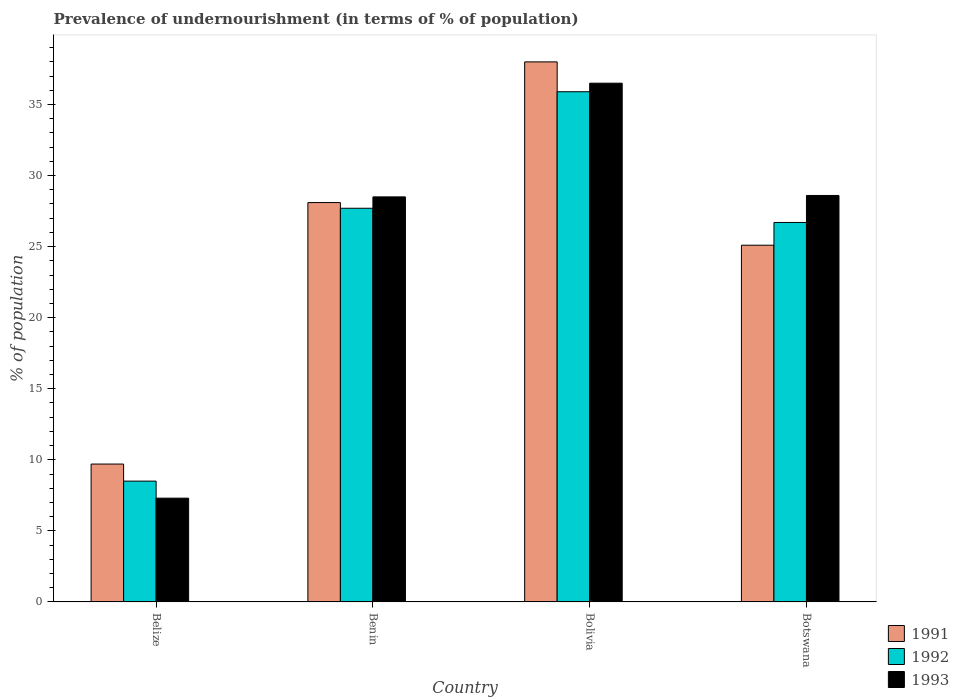Are the number of bars per tick equal to the number of legend labels?
Make the answer very short. Yes. What is the label of the 1st group of bars from the left?
Give a very brief answer. Belize. What is the percentage of undernourished population in 1993 in Benin?
Your answer should be compact. 28.5. Across all countries, what is the maximum percentage of undernourished population in 1993?
Keep it short and to the point. 36.5. In which country was the percentage of undernourished population in 1992 minimum?
Offer a very short reply. Belize. What is the total percentage of undernourished population in 1991 in the graph?
Provide a succinct answer. 100.9. What is the difference between the percentage of undernourished population in 1993 in Bolivia and that in Botswana?
Make the answer very short. 7.9. What is the difference between the percentage of undernourished population in 1991 in Bolivia and the percentage of undernourished population in 1993 in Benin?
Your answer should be compact. 9.5. What is the average percentage of undernourished population in 1993 per country?
Offer a very short reply. 25.23. What is the difference between the percentage of undernourished population of/in 1992 and percentage of undernourished population of/in 1991 in Benin?
Give a very brief answer. -0.4. In how many countries, is the percentage of undernourished population in 1992 greater than 14 %?
Your answer should be very brief. 3. What is the ratio of the percentage of undernourished population in 1992 in Belize to that in Bolivia?
Your answer should be compact. 0.24. Is the percentage of undernourished population in 1991 in Belize less than that in Botswana?
Your response must be concise. Yes. Is the difference between the percentage of undernourished population in 1992 in Belize and Bolivia greater than the difference between the percentage of undernourished population in 1991 in Belize and Bolivia?
Provide a succinct answer. Yes. What is the difference between the highest and the second highest percentage of undernourished population in 1991?
Ensure brevity in your answer.  -3. What is the difference between the highest and the lowest percentage of undernourished population in 1993?
Provide a succinct answer. 29.2. In how many countries, is the percentage of undernourished population in 1991 greater than the average percentage of undernourished population in 1991 taken over all countries?
Make the answer very short. 2. What does the 3rd bar from the left in Belize represents?
Your answer should be very brief. 1993. Is it the case that in every country, the sum of the percentage of undernourished population in 1992 and percentage of undernourished population in 1993 is greater than the percentage of undernourished population in 1991?
Provide a short and direct response. Yes. Are all the bars in the graph horizontal?
Offer a very short reply. No. Are the values on the major ticks of Y-axis written in scientific E-notation?
Provide a succinct answer. No. Does the graph contain any zero values?
Offer a terse response. No. Does the graph contain grids?
Your answer should be compact. No. Where does the legend appear in the graph?
Give a very brief answer. Bottom right. How are the legend labels stacked?
Make the answer very short. Vertical. What is the title of the graph?
Offer a terse response. Prevalence of undernourishment (in terms of % of population). Does "1970" appear as one of the legend labels in the graph?
Offer a terse response. No. What is the label or title of the X-axis?
Keep it short and to the point. Country. What is the label or title of the Y-axis?
Offer a very short reply. % of population. What is the % of population of 1991 in Benin?
Ensure brevity in your answer.  28.1. What is the % of population of 1992 in Benin?
Provide a succinct answer. 27.7. What is the % of population in 1993 in Benin?
Provide a succinct answer. 28.5. What is the % of population in 1991 in Bolivia?
Offer a terse response. 38. What is the % of population in 1992 in Bolivia?
Give a very brief answer. 35.9. What is the % of population in 1993 in Bolivia?
Keep it short and to the point. 36.5. What is the % of population of 1991 in Botswana?
Make the answer very short. 25.1. What is the % of population of 1992 in Botswana?
Offer a very short reply. 26.7. What is the % of population of 1993 in Botswana?
Your answer should be compact. 28.6. Across all countries, what is the maximum % of population of 1991?
Keep it short and to the point. 38. Across all countries, what is the maximum % of population of 1992?
Offer a very short reply. 35.9. Across all countries, what is the maximum % of population of 1993?
Your answer should be compact. 36.5. What is the total % of population of 1991 in the graph?
Your answer should be compact. 100.9. What is the total % of population in 1992 in the graph?
Offer a terse response. 98.8. What is the total % of population in 1993 in the graph?
Offer a terse response. 100.9. What is the difference between the % of population in 1991 in Belize and that in Benin?
Provide a succinct answer. -18.4. What is the difference between the % of population in 1992 in Belize and that in Benin?
Your answer should be very brief. -19.2. What is the difference between the % of population of 1993 in Belize and that in Benin?
Give a very brief answer. -21.2. What is the difference between the % of population in 1991 in Belize and that in Bolivia?
Provide a succinct answer. -28.3. What is the difference between the % of population in 1992 in Belize and that in Bolivia?
Offer a very short reply. -27.4. What is the difference between the % of population in 1993 in Belize and that in Bolivia?
Provide a succinct answer. -29.2. What is the difference between the % of population in 1991 in Belize and that in Botswana?
Offer a terse response. -15.4. What is the difference between the % of population in 1992 in Belize and that in Botswana?
Offer a terse response. -18.2. What is the difference between the % of population of 1993 in Belize and that in Botswana?
Provide a succinct answer. -21.3. What is the difference between the % of population of 1993 in Benin and that in Bolivia?
Your answer should be very brief. -8. What is the difference between the % of population of 1991 in Benin and that in Botswana?
Offer a very short reply. 3. What is the difference between the % of population in 1993 in Benin and that in Botswana?
Provide a succinct answer. -0.1. What is the difference between the % of population in 1991 in Bolivia and that in Botswana?
Give a very brief answer. 12.9. What is the difference between the % of population of 1991 in Belize and the % of population of 1993 in Benin?
Provide a succinct answer. -18.8. What is the difference between the % of population of 1991 in Belize and the % of population of 1992 in Bolivia?
Your response must be concise. -26.2. What is the difference between the % of population in 1991 in Belize and the % of population in 1993 in Bolivia?
Your response must be concise. -26.8. What is the difference between the % of population of 1991 in Belize and the % of population of 1993 in Botswana?
Your response must be concise. -18.9. What is the difference between the % of population in 1992 in Belize and the % of population in 1993 in Botswana?
Offer a very short reply. -20.1. What is the difference between the % of population of 1991 in Benin and the % of population of 1993 in Bolivia?
Your answer should be very brief. -8.4. What is the difference between the % of population of 1991 in Benin and the % of population of 1992 in Botswana?
Offer a very short reply. 1.4. What is the difference between the % of population in 1991 in Benin and the % of population in 1993 in Botswana?
Ensure brevity in your answer.  -0.5. What is the difference between the % of population of 1992 in Benin and the % of population of 1993 in Botswana?
Offer a terse response. -0.9. What is the difference between the % of population of 1991 in Bolivia and the % of population of 1992 in Botswana?
Give a very brief answer. 11.3. What is the difference between the % of population of 1992 in Bolivia and the % of population of 1993 in Botswana?
Give a very brief answer. 7.3. What is the average % of population of 1991 per country?
Ensure brevity in your answer.  25.23. What is the average % of population in 1992 per country?
Provide a succinct answer. 24.7. What is the average % of population of 1993 per country?
Give a very brief answer. 25.23. What is the difference between the % of population of 1991 and % of population of 1993 in Belize?
Offer a very short reply. 2.4. What is the difference between the % of population of 1991 and % of population of 1992 in Benin?
Ensure brevity in your answer.  0.4. What is the difference between the % of population of 1991 and % of population of 1993 in Benin?
Keep it short and to the point. -0.4. What is the difference between the % of population in 1991 and % of population in 1993 in Bolivia?
Offer a terse response. 1.5. What is the difference between the % of population in 1992 and % of population in 1993 in Botswana?
Give a very brief answer. -1.9. What is the ratio of the % of population in 1991 in Belize to that in Benin?
Offer a very short reply. 0.35. What is the ratio of the % of population in 1992 in Belize to that in Benin?
Your answer should be compact. 0.31. What is the ratio of the % of population in 1993 in Belize to that in Benin?
Keep it short and to the point. 0.26. What is the ratio of the % of population of 1991 in Belize to that in Bolivia?
Make the answer very short. 0.26. What is the ratio of the % of population of 1992 in Belize to that in Bolivia?
Your response must be concise. 0.24. What is the ratio of the % of population in 1991 in Belize to that in Botswana?
Ensure brevity in your answer.  0.39. What is the ratio of the % of population in 1992 in Belize to that in Botswana?
Your response must be concise. 0.32. What is the ratio of the % of population in 1993 in Belize to that in Botswana?
Your answer should be very brief. 0.26. What is the ratio of the % of population of 1991 in Benin to that in Bolivia?
Give a very brief answer. 0.74. What is the ratio of the % of population in 1992 in Benin to that in Bolivia?
Provide a succinct answer. 0.77. What is the ratio of the % of population in 1993 in Benin to that in Bolivia?
Provide a short and direct response. 0.78. What is the ratio of the % of population in 1991 in Benin to that in Botswana?
Your answer should be very brief. 1.12. What is the ratio of the % of population of 1992 in Benin to that in Botswana?
Your answer should be compact. 1.04. What is the ratio of the % of population in 1993 in Benin to that in Botswana?
Provide a succinct answer. 1. What is the ratio of the % of population in 1991 in Bolivia to that in Botswana?
Offer a very short reply. 1.51. What is the ratio of the % of population of 1992 in Bolivia to that in Botswana?
Give a very brief answer. 1.34. What is the ratio of the % of population in 1993 in Bolivia to that in Botswana?
Your answer should be very brief. 1.28. What is the difference between the highest and the second highest % of population in 1991?
Provide a short and direct response. 9.9. What is the difference between the highest and the second highest % of population of 1993?
Your answer should be very brief. 7.9. What is the difference between the highest and the lowest % of population in 1991?
Make the answer very short. 28.3. What is the difference between the highest and the lowest % of population of 1992?
Make the answer very short. 27.4. What is the difference between the highest and the lowest % of population of 1993?
Make the answer very short. 29.2. 